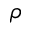<formula> <loc_0><loc_0><loc_500><loc_500>\rho</formula> 